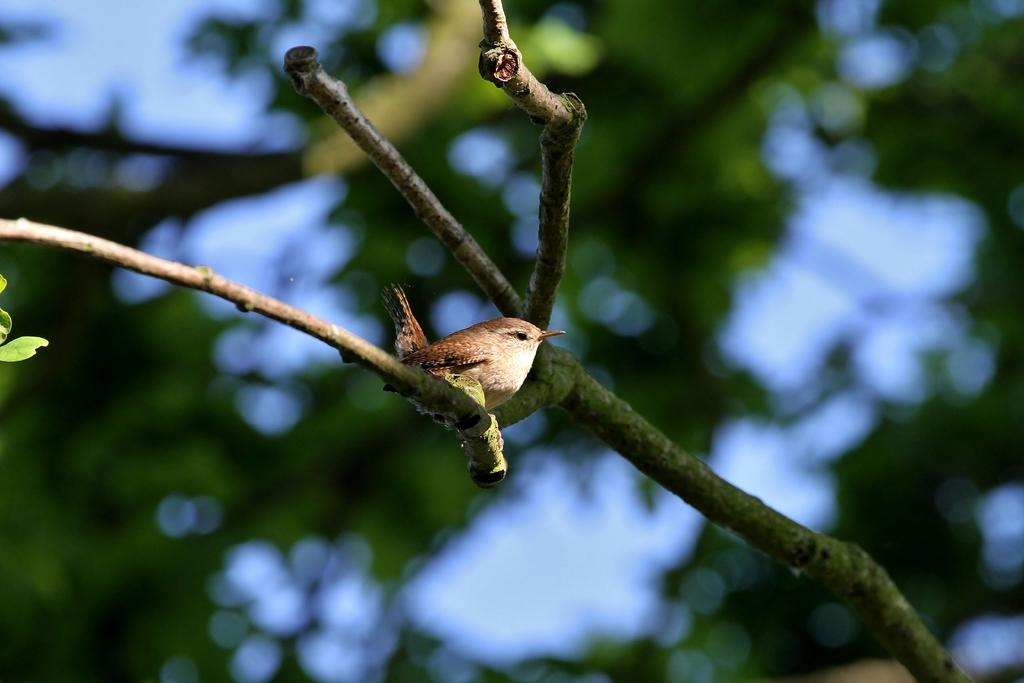What type of animal is in the image? There is a bird in the image. Where is the bird located? The bird is standing on a tree stem. What can be seen in the image besides the bird? There are leaves visible in the image. What colors are present in the background of the image? The background of the image includes green and white colors. Is there a meeting happening in the image? There is no indication of a meeting in the image; it features a bird standing on a tree stem with leaves and a green and white background. 